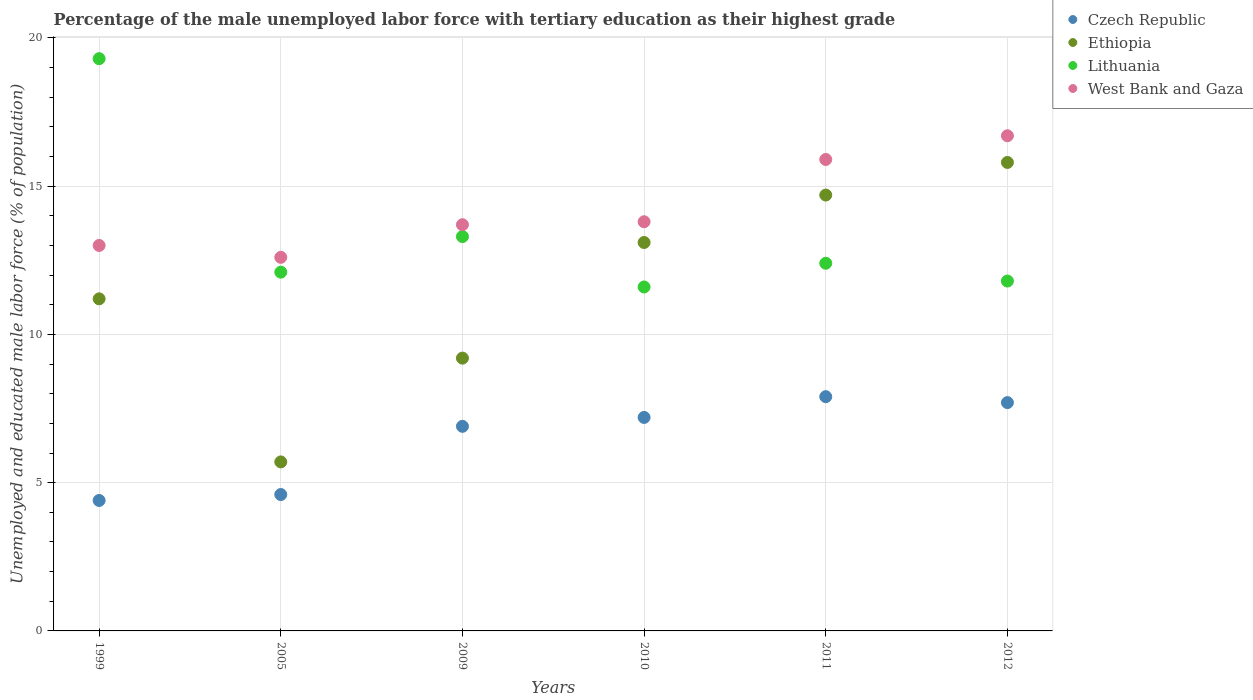Is the number of dotlines equal to the number of legend labels?
Provide a short and direct response. Yes. What is the percentage of the unemployed male labor force with tertiary education in Lithuania in 2010?
Provide a short and direct response. 11.6. Across all years, what is the maximum percentage of the unemployed male labor force with tertiary education in West Bank and Gaza?
Your answer should be very brief. 16.7. Across all years, what is the minimum percentage of the unemployed male labor force with tertiary education in Czech Republic?
Provide a succinct answer. 4.4. What is the total percentage of the unemployed male labor force with tertiary education in Lithuania in the graph?
Your answer should be compact. 80.5. What is the difference between the percentage of the unemployed male labor force with tertiary education in Czech Republic in 2005 and that in 2010?
Provide a short and direct response. -2.6. What is the difference between the percentage of the unemployed male labor force with tertiary education in Lithuania in 2011 and the percentage of the unemployed male labor force with tertiary education in Czech Republic in 2010?
Provide a short and direct response. 5.2. What is the average percentage of the unemployed male labor force with tertiary education in Lithuania per year?
Offer a terse response. 13.42. In the year 2012, what is the difference between the percentage of the unemployed male labor force with tertiary education in Ethiopia and percentage of the unemployed male labor force with tertiary education in West Bank and Gaza?
Offer a terse response. -0.9. What is the ratio of the percentage of the unemployed male labor force with tertiary education in Lithuania in 2005 to that in 2012?
Your answer should be compact. 1.03. Is the percentage of the unemployed male labor force with tertiary education in Lithuania in 2009 less than that in 2010?
Your answer should be very brief. No. What is the difference between the highest and the second highest percentage of the unemployed male labor force with tertiary education in Czech Republic?
Provide a succinct answer. 0.2. What is the difference between the highest and the lowest percentage of the unemployed male labor force with tertiary education in West Bank and Gaza?
Keep it short and to the point. 4.1. In how many years, is the percentage of the unemployed male labor force with tertiary education in West Bank and Gaza greater than the average percentage of the unemployed male labor force with tertiary education in West Bank and Gaza taken over all years?
Provide a succinct answer. 2. Is the sum of the percentage of the unemployed male labor force with tertiary education in Czech Republic in 2010 and 2011 greater than the maximum percentage of the unemployed male labor force with tertiary education in Lithuania across all years?
Make the answer very short. No. Is it the case that in every year, the sum of the percentage of the unemployed male labor force with tertiary education in Czech Republic and percentage of the unemployed male labor force with tertiary education in Lithuania  is greater than the percentage of the unemployed male labor force with tertiary education in Ethiopia?
Make the answer very short. Yes. Does the percentage of the unemployed male labor force with tertiary education in Lithuania monotonically increase over the years?
Your answer should be compact. No. How many years are there in the graph?
Your response must be concise. 6. Where does the legend appear in the graph?
Make the answer very short. Top right. How are the legend labels stacked?
Keep it short and to the point. Vertical. What is the title of the graph?
Make the answer very short. Percentage of the male unemployed labor force with tertiary education as their highest grade. Does "Jamaica" appear as one of the legend labels in the graph?
Make the answer very short. No. What is the label or title of the X-axis?
Make the answer very short. Years. What is the label or title of the Y-axis?
Offer a terse response. Unemployed and educated male labor force (% of population). What is the Unemployed and educated male labor force (% of population) in Czech Republic in 1999?
Ensure brevity in your answer.  4.4. What is the Unemployed and educated male labor force (% of population) in Ethiopia in 1999?
Ensure brevity in your answer.  11.2. What is the Unemployed and educated male labor force (% of population) of Lithuania in 1999?
Offer a terse response. 19.3. What is the Unemployed and educated male labor force (% of population) in Czech Republic in 2005?
Give a very brief answer. 4.6. What is the Unemployed and educated male labor force (% of population) of Ethiopia in 2005?
Keep it short and to the point. 5.7. What is the Unemployed and educated male labor force (% of population) in Lithuania in 2005?
Ensure brevity in your answer.  12.1. What is the Unemployed and educated male labor force (% of population) in West Bank and Gaza in 2005?
Give a very brief answer. 12.6. What is the Unemployed and educated male labor force (% of population) of Czech Republic in 2009?
Your answer should be very brief. 6.9. What is the Unemployed and educated male labor force (% of population) of Ethiopia in 2009?
Give a very brief answer. 9.2. What is the Unemployed and educated male labor force (% of population) in Lithuania in 2009?
Your answer should be compact. 13.3. What is the Unemployed and educated male labor force (% of population) of West Bank and Gaza in 2009?
Provide a short and direct response. 13.7. What is the Unemployed and educated male labor force (% of population) of Czech Republic in 2010?
Provide a succinct answer. 7.2. What is the Unemployed and educated male labor force (% of population) in Ethiopia in 2010?
Offer a very short reply. 13.1. What is the Unemployed and educated male labor force (% of population) in Lithuania in 2010?
Your answer should be compact. 11.6. What is the Unemployed and educated male labor force (% of population) of West Bank and Gaza in 2010?
Offer a terse response. 13.8. What is the Unemployed and educated male labor force (% of population) of Czech Republic in 2011?
Keep it short and to the point. 7.9. What is the Unemployed and educated male labor force (% of population) of Ethiopia in 2011?
Your answer should be compact. 14.7. What is the Unemployed and educated male labor force (% of population) of Lithuania in 2011?
Provide a succinct answer. 12.4. What is the Unemployed and educated male labor force (% of population) in West Bank and Gaza in 2011?
Your answer should be compact. 15.9. What is the Unemployed and educated male labor force (% of population) in Czech Republic in 2012?
Keep it short and to the point. 7.7. What is the Unemployed and educated male labor force (% of population) in Ethiopia in 2012?
Your answer should be very brief. 15.8. What is the Unemployed and educated male labor force (% of population) of Lithuania in 2012?
Your answer should be very brief. 11.8. What is the Unemployed and educated male labor force (% of population) in West Bank and Gaza in 2012?
Offer a terse response. 16.7. Across all years, what is the maximum Unemployed and educated male labor force (% of population) of Czech Republic?
Your response must be concise. 7.9. Across all years, what is the maximum Unemployed and educated male labor force (% of population) of Ethiopia?
Provide a short and direct response. 15.8. Across all years, what is the maximum Unemployed and educated male labor force (% of population) of Lithuania?
Give a very brief answer. 19.3. Across all years, what is the maximum Unemployed and educated male labor force (% of population) of West Bank and Gaza?
Ensure brevity in your answer.  16.7. Across all years, what is the minimum Unemployed and educated male labor force (% of population) of Czech Republic?
Provide a short and direct response. 4.4. Across all years, what is the minimum Unemployed and educated male labor force (% of population) of Ethiopia?
Provide a succinct answer. 5.7. Across all years, what is the minimum Unemployed and educated male labor force (% of population) of Lithuania?
Ensure brevity in your answer.  11.6. Across all years, what is the minimum Unemployed and educated male labor force (% of population) in West Bank and Gaza?
Provide a succinct answer. 12.6. What is the total Unemployed and educated male labor force (% of population) of Czech Republic in the graph?
Give a very brief answer. 38.7. What is the total Unemployed and educated male labor force (% of population) of Ethiopia in the graph?
Keep it short and to the point. 69.7. What is the total Unemployed and educated male labor force (% of population) in Lithuania in the graph?
Your answer should be very brief. 80.5. What is the total Unemployed and educated male labor force (% of population) of West Bank and Gaza in the graph?
Make the answer very short. 85.7. What is the difference between the Unemployed and educated male labor force (% of population) in Lithuania in 1999 and that in 2005?
Offer a very short reply. 7.2. What is the difference between the Unemployed and educated male labor force (% of population) in Ethiopia in 1999 and that in 2009?
Provide a succinct answer. 2. What is the difference between the Unemployed and educated male labor force (% of population) in West Bank and Gaza in 1999 and that in 2009?
Ensure brevity in your answer.  -0.7. What is the difference between the Unemployed and educated male labor force (% of population) in Czech Republic in 1999 and that in 2010?
Make the answer very short. -2.8. What is the difference between the Unemployed and educated male labor force (% of population) in Ethiopia in 1999 and that in 2010?
Offer a very short reply. -1.9. What is the difference between the Unemployed and educated male labor force (% of population) in Czech Republic in 1999 and that in 2012?
Offer a terse response. -3.3. What is the difference between the Unemployed and educated male labor force (% of population) of Ethiopia in 1999 and that in 2012?
Your response must be concise. -4.6. What is the difference between the Unemployed and educated male labor force (% of population) in Lithuania in 1999 and that in 2012?
Provide a short and direct response. 7.5. What is the difference between the Unemployed and educated male labor force (% of population) of Ethiopia in 2005 and that in 2009?
Make the answer very short. -3.5. What is the difference between the Unemployed and educated male labor force (% of population) in West Bank and Gaza in 2005 and that in 2009?
Your answer should be compact. -1.1. What is the difference between the Unemployed and educated male labor force (% of population) of Ethiopia in 2005 and that in 2010?
Keep it short and to the point. -7.4. What is the difference between the Unemployed and educated male labor force (% of population) in Czech Republic in 2005 and that in 2011?
Provide a short and direct response. -3.3. What is the difference between the Unemployed and educated male labor force (% of population) of Ethiopia in 2005 and that in 2011?
Make the answer very short. -9. What is the difference between the Unemployed and educated male labor force (% of population) in Ethiopia in 2005 and that in 2012?
Keep it short and to the point. -10.1. What is the difference between the Unemployed and educated male labor force (% of population) of Lithuania in 2005 and that in 2012?
Provide a short and direct response. 0.3. What is the difference between the Unemployed and educated male labor force (% of population) in Lithuania in 2009 and that in 2010?
Make the answer very short. 1.7. What is the difference between the Unemployed and educated male labor force (% of population) in Ethiopia in 2009 and that in 2011?
Provide a short and direct response. -5.5. What is the difference between the Unemployed and educated male labor force (% of population) in Lithuania in 2009 and that in 2011?
Your answer should be compact. 0.9. What is the difference between the Unemployed and educated male labor force (% of population) in Czech Republic in 2009 and that in 2012?
Make the answer very short. -0.8. What is the difference between the Unemployed and educated male labor force (% of population) in Ethiopia in 2009 and that in 2012?
Give a very brief answer. -6.6. What is the difference between the Unemployed and educated male labor force (% of population) in Lithuania in 2009 and that in 2012?
Keep it short and to the point. 1.5. What is the difference between the Unemployed and educated male labor force (% of population) of West Bank and Gaza in 2009 and that in 2012?
Your answer should be compact. -3. What is the difference between the Unemployed and educated male labor force (% of population) of Lithuania in 2010 and that in 2011?
Ensure brevity in your answer.  -0.8. What is the difference between the Unemployed and educated male labor force (% of population) of Lithuania in 2010 and that in 2012?
Your response must be concise. -0.2. What is the difference between the Unemployed and educated male labor force (% of population) in West Bank and Gaza in 2010 and that in 2012?
Ensure brevity in your answer.  -2.9. What is the difference between the Unemployed and educated male labor force (% of population) in Lithuania in 2011 and that in 2012?
Your answer should be compact. 0.6. What is the difference between the Unemployed and educated male labor force (% of population) in Czech Republic in 1999 and the Unemployed and educated male labor force (% of population) in Ethiopia in 2005?
Keep it short and to the point. -1.3. What is the difference between the Unemployed and educated male labor force (% of population) in Ethiopia in 1999 and the Unemployed and educated male labor force (% of population) in West Bank and Gaza in 2005?
Your answer should be compact. -1.4. What is the difference between the Unemployed and educated male labor force (% of population) in Lithuania in 1999 and the Unemployed and educated male labor force (% of population) in West Bank and Gaza in 2005?
Keep it short and to the point. 6.7. What is the difference between the Unemployed and educated male labor force (% of population) of Czech Republic in 1999 and the Unemployed and educated male labor force (% of population) of Ethiopia in 2009?
Keep it short and to the point. -4.8. What is the difference between the Unemployed and educated male labor force (% of population) in Ethiopia in 1999 and the Unemployed and educated male labor force (% of population) in Lithuania in 2009?
Ensure brevity in your answer.  -2.1. What is the difference between the Unemployed and educated male labor force (% of population) of Ethiopia in 1999 and the Unemployed and educated male labor force (% of population) of West Bank and Gaza in 2009?
Your answer should be very brief. -2.5. What is the difference between the Unemployed and educated male labor force (% of population) of Czech Republic in 1999 and the Unemployed and educated male labor force (% of population) of Ethiopia in 2010?
Provide a short and direct response. -8.7. What is the difference between the Unemployed and educated male labor force (% of population) of Czech Republic in 1999 and the Unemployed and educated male labor force (% of population) of Lithuania in 2010?
Make the answer very short. -7.2. What is the difference between the Unemployed and educated male labor force (% of population) of Czech Republic in 1999 and the Unemployed and educated male labor force (% of population) of West Bank and Gaza in 2010?
Your response must be concise. -9.4. What is the difference between the Unemployed and educated male labor force (% of population) in Ethiopia in 1999 and the Unemployed and educated male labor force (% of population) in Lithuania in 2010?
Provide a short and direct response. -0.4. What is the difference between the Unemployed and educated male labor force (% of population) in Lithuania in 1999 and the Unemployed and educated male labor force (% of population) in West Bank and Gaza in 2010?
Provide a succinct answer. 5.5. What is the difference between the Unemployed and educated male labor force (% of population) in Czech Republic in 1999 and the Unemployed and educated male labor force (% of population) in Ethiopia in 2011?
Keep it short and to the point. -10.3. What is the difference between the Unemployed and educated male labor force (% of population) of Czech Republic in 1999 and the Unemployed and educated male labor force (% of population) of Lithuania in 2011?
Make the answer very short. -8. What is the difference between the Unemployed and educated male labor force (% of population) of Ethiopia in 1999 and the Unemployed and educated male labor force (% of population) of Lithuania in 2011?
Provide a succinct answer. -1.2. What is the difference between the Unemployed and educated male labor force (% of population) in Lithuania in 1999 and the Unemployed and educated male labor force (% of population) in West Bank and Gaza in 2011?
Provide a succinct answer. 3.4. What is the difference between the Unemployed and educated male labor force (% of population) of Czech Republic in 1999 and the Unemployed and educated male labor force (% of population) of Ethiopia in 2012?
Your answer should be very brief. -11.4. What is the difference between the Unemployed and educated male labor force (% of population) in Czech Republic in 1999 and the Unemployed and educated male labor force (% of population) in West Bank and Gaza in 2012?
Make the answer very short. -12.3. What is the difference between the Unemployed and educated male labor force (% of population) in Ethiopia in 1999 and the Unemployed and educated male labor force (% of population) in Lithuania in 2012?
Provide a short and direct response. -0.6. What is the difference between the Unemployed and educated male labor force (% of population) in Ethiopia in 1999 and the Unemployed and educated male labor force (% of population) in West Bank and Gaza in 2012?
Offer a terse response. -5.5. What is the difference between the Unemployed and educated male labor force (% of population) of Czech Republic in 2005 and the Unemployed and educated male labor force (% of population) of West Bank and Gaza in 2009?
Offer a terse response. -9.1. What is the difference between the Unemployed and educated male labor force (% of population) in Ethiopia in 2005 and the Unemployed and educated male labor force (% of population) in Lithuania in 2009?
Provide a short and direct response. -7.6. What is the difference between the Unemployed and educated male labor force (% of population) of Lithuania in 2005 and the Unemployed and educated male labor force (% of population) of West Bank and Gaza in 2009?
Keep it short and to the point. -1.6. What is the difference between the Unemployed and educated male labor force (% of population) of Ethiopia in 2005 and the Unemployed and educated male labor force (% of population) of Lithuania in 2010?
Give a very brief answer. -5.9. What is the difference between the Unemployed and educated male labor force (% of population) in Ethiopia in 2005 and the Unemployed and educated male labor force (% of population) in West Bank and Gaza in 2010?
Provide a succinct answer. -8.1. What is the difference between the Unemployed and educated male labor force (% of population) in Czech Republic in 2005 and the Unemployed and educated male labor force (% of population) in Ethiopia in 2011?
Offer a terse response. -10.1. What is the difference between the Unemployed and educated male labor force (% of population) in Czech Republic in 2005 and the Unemployed and educated male labor force (% of population) in Lithuania in 2011?
Ensure brevity in your answer.  -7.8. What is the difference between the Unemployed and educated male labor force (% of population) of Czech Republic in 2005 and the Unemployed and educated male labor force (% of population) of West Bank and Gaza in 2011?
Make the answer very short. -11.3. What is the difference between the Unemployed and educated male labor force (% of population) in Ethiopia in 2005 and the Unemployed and educated male labor force (% of population) in Lithuania in 2011?
Give a very brief answer. -6.7. What is the difference between the Unemployed and educated male labor force (% of population) of Ethiopia in 2005 and the Unemployed and educated male labor force (% of population) of West Bank and Gaza in 2012?
Offer a very short reply. -11. What is the difference between the Unemployed and educated male labor force (% of population) in Czech Republic in 2009 and the Unemployed and educated male labor force (% of population) in Ethiopia in 2010?
Make the answer very short. -6.2. What is the difference between the Unemployed and educated male labor force (% of population) of Czech Republic in 2009 and the Unemployed and educated male labor force (% of population) of Lithuania in 2010?
Ensure brevity in your answer.  -4.7. What is the difference between the Unemployed and educated male labor force (% of population) in Czech Republic in 2009 and the Unemployed and educated male labor force (% of population) in West Bank and Gaza in 2010?
Make the answer very short. -6.9. What is the difference between the Unemployed and educated male labor force (% of population) in Lithuania in 2009 and the Unemployed and educated male labor force (% of population) in West Bank and Gaza in 2010?
Ensure brevity in your answer.  -0.5. What is the difference between the Unemployed and educated male labor force (% of population) of Czech Republic in 2009 and the Unemployed and educated male labor force (% of population) of Ethiopia in 2011?
Keep it short and to the point. -7.8. What is the difference between the Unemployed and educated male labor force (% of population) of Czech Republic in 2009 and the Unemployed and educated male labor force (% of population) of Lithuania in 2011?
Give a very brief answer. -5.5. What is the difference between the Unemployed and educated male labor force (% of population) in Czech Republic in 2009 and the Unemployed and educated male labor force (% of population) in West Bank and Gaza in 2011?
Make the answer very short. -9. What is the difference between the Unemployed and educated male labor force (% of population) of Ethiopia in 2009 and the Unemployed and educated male labor force (% of population) of Lithuania in 2011?
Ensure brevity in your answer.  -3.2. What is the difference between the Unemployed and educated male labor force (% of population) in Ethiopia in 2009 and the Unemployed and educated male labor force (% of population) in West Bank and Gaza in 2011?
Offer a very short reply. -6.7. What is the difference between the Unemployed and educated male labor force (% of population) in Czech Republic in 2009 and the Unemployed and educated male labor force (% of population) in Lithuania in 2012?
Your response must be concise. -4.9. What is the difference between the Unemployed and educated male labor force (% of population) of Ethiopia in 2009 and the Unemployed and educated male labor force (% of population) of West Bank and Gaza in 2012?
Keep it short and to the point. -7.5. What is the difference between the Unemployed and educated male labor force (% of population) in Lithuania in 2009 and the Unemployed and educated male labor force (% of population) in West Bank and Gaza in 2012?
Provide a succinct answer. -3.4. What is the difference between the Unemployed and educated male labor force (% of population) in Czech Republic in 2010 and the Unemployed and educated male labor force (% of population) in Ethiopia in 2011?
Your answer should be compact. -7.5. What is the difference between the Unemployed and educated male labor force (% of population) of Czech Republic in 2010 and the Unemployed and educated male labor force (% of population) of West Bank and Gaza in 2011?
Make the answer very short. -8.7. What is the difference between the Unemployed and educated male labor force (% of population) of Ethiopia in 2010 and the Unemployed and educated male labor force (% of population) of West Bank and Gaza in 2011?
Ensure brevity in your answer.  -2.8. What is the difference between the Unemployed and educated male labor force (% of population) of Czech Republic in 2010 and the Unemployed and educated male labor force (% of population) of Ethiopia in 2012?
Provide a succinct answer. -8.6. What is the difference between the Unemployed and educated male labor force (% of population) of Ethiopia in 2010 and the Unemployed and educated male labor force (% of population) of Lithuania in 2012?
Provide a succinct answer. 1.3. What is the difference between the Unemployed and educated male labor force (% of population) in Czech Republic in 2011 and the Unemployed and educated male labor force (% of population) in Ethiopia in 2012?
Your answer should be compact. -7.9. What is the difference between the Unemployed and educated male labor force (% of population) of Czech Republic in 2011 and the Unemployed and educated male labor force (% of population) of Lithuania in 2012?
Offer a very short reply. -3.9. What is the difference between the Unemployed and educated male labor force (% of population) in Czech Republic in 2011 and the Unemployed and educated male labor force (% of population) in West Bank and Gaza in 2012?
Give a very brief answer. -8.8. What is the difference between the Unemployed and educated male labor force (% of population) in Ethiopia in 2011 and the Unemployed and educated male labor force (% of population) in Lithuania in 2012?
Provide a short and direct response. 2.9. What is the difference between the Unemployed and educated male labor force (% of population) of Ethiopia in 2011 and the Unemployed and educated male labor force (% of population) of West Bank and Gaza in 2012?
Provide a short and direct response. -2. What is the difference between the Unemployed and educated male labor force (% of population) of Lithuania in 2011 and the Unemployed and educated male labor force (% of population) of West Bank and Gaza in 2012?
Your response must be concise. -4.3. What is the average Unemployed and educated male labor force (% of population) in Czech Republic per year?
Your answer should be very brief. 6.45. What is the average Unemployed and educated male labor force (% of population) of Ethiopia per year?
Offer a very short reply. 11.62. What is the average Unemployed and educated male labor force (% of population) in Lithuania per year?
Make the answer very short. 13.42. What is the average Unemployed and educated male labor force (% of population) of West Bank and Gaza per year?
Offer a terse response. 14.28. In the year 1999, what is the difference between the Unemployed and educated male labor force (% of population) of Czech Republic and Unemployed and educated male labor force (% of population) of Lithuania?
Keep it short and to the point. -14.9. In the year 2005, what is the difference between the Unemployed and educated male labor force (% of population) of Czech Republic and Unemployed and educated male labor force (% of population) of Ethiopia?
Your answer should be compact. -1.1. In the year 2005, what is the difference between the Unemployed and educated male labor force (% of population) in Czech Republic and Unemployed and educated male labor force (% of population) in West Bank and Gaza?
Provide a short and direct response. -8. In the year 2005, what is the difference between the Unemployed and educated male labor force (% of population) in Lithuania and Unemployed and educated male labor force (% of population) in West Bank and Gaza?
Your response must be concise. -0.5. In the year 2009, what is the difference between the Unemployed and educated male labor force (% of population) of Czech Republic and Unemployed and educated male labor force (% of population) of Ethiopia?
Keep it short and to the point. -2.3. In the year 2009, what is the difference between the Unemployed and educated male labor force (% of population) of Czech Republic and Unemployed and educated male labor force (% of population) of Lithuania?
Provide a succinct answer. -6.4. In the year 2010, what is the difference between the Unemployed and educated male labor force (% of population) in Czech Republic and Unemployed and educated male labor force (% of population) in Ethiopia?
Your response must be concise. -5.9. In the year 2010, what is the difference between the Unemployed and educated male labor force (% of population) of Czech Republic and Unemployed and educated male labor force (% of population) of West Bank and Gaza?
Provide a short and direct response. -6.6. In the year 2010, what is the difference between the Unemployed and educated male labor force (% of population) in Ethiopia and Unemployed and educated male labor force (% of population) in West Bank and Gaza?
Provide a succinct answer. -0.7. In the year 2010, what is the difference between the Unemployed and educated male labor force (% of population) in Lithuania and Unemployed and educated male labor force (% of population) in West Bank and Gaza?
Make the answer very short. -2.2. In the year 2011, what is the difference between the Unemployed and educated male labor force (% of population) of Czech Republic and Unemployed and educated male labor force (% of population) of Ethiopia?
Make the answer very short. -6.8. In the year 2011, what is the difference between the Unemployed and educated male labor force (% of population) of Czech Republic and Unemployed and educated male labor force (% of population) of Lithuania?
Offer a very short reply. -4.5. In the year 2011, what is the difference between the Unemployed and educated male labor force (% of population) in Ethiopia and Unemployed and educated male labor force (% of population) in Lithuania?
Give a very brief answer. 2.3. In the year 2011, what is the difference between the Unemployed and educated male labor force (% of population) in Ethiopia and Unemployed and educated male labor force (% of population) in West Bank and Gaza?
Ensure brevity in your answer.  -1.2. In the year 2012, what is the difference between the Unemployed and educated male labor force (% of population) of Czech Republic and Unemployed and educated male labor force (% of population) of Ethiopia?
Offer a terse response. -8.1. In the year 2012, what is the difference between the Unemployed and educated male labor force (% of population) in Ethiopia and Unemployed and educated male labor force (% of population) in West Bank and Gaza?
Your answer should be compact. -0.9. What is the ratio of the Unemployed and educated male labor force (% of population) of Czech Republic in 1999 to that in 2005?
Your answer should be compact. 0.96. What is the ratio of the Unemployed and educated male labor force (% of population) in Ethiopia in 1999 to that in 2005?
Give a very brief answer. 1.96. What is the ratio of the Unemployed and educated male labor force (% of population) in Lithuania in 1999 to that in 2005?
Your answer should be compact. 1.59. What is the ratio of the Unemployed and educated male labor force (% of population) in West Bank and Gaza in 1999 to that in 2005?
Ensure brevity in your answer.  1.03. What is the ratio of the Unemployed and educated male labor force (% of population) of Czech Republic in 1999 to that in 2009?
Your response must be concise. 0.64. What is the ratio of the Unemployed and educated male labor force (% of population) in Ethiopia in 1999 to that in 2009?
Provide a short and direct response. 1.22. What is the ratio of the Unemployed and educated male labor force (% of population) of Lithuania in 1999 to that in 2009?
Keep it short and to the point. 1.45. What is the ratio of the Unemployed and educated male labor force (% of population) of West Bank and Gaza in 1999 to that in 2009?
Give a very brief answer. 0.95. What is the ratio of the Unemployed and educated male labor force (% of population) in Czech Republic in 1999 to that in 2010?
Keep it short and to the point. 0.61. What is the ratio of the Unemployed and educated male labor force (% of population) in Ethiopia in 1999 to that in 2010?
Give a very brief answer. 0.85. What is the ratio of the Unemployed and educated male labor force (% of population) of Lithuania in 1999 to that in 2010?
Offer a terse response. 1.66. What is the ratio of the Unemployed and educated male labor force (% of population) in West Bank and Gaza in 1999 to that in 2010?
Provide a short and direct response. 0.94. What is the ratio of the Unemployed and educated male labor force (% of population) in Czech Republic in 1999 to that in 2011?
Ensure brevity in your answer.  0.56. What is the ratio of the Unemployed and educated male labor force (% of population) in Ethiopia in 1999 to that in 2011?
Offer a very short reply. 0.76. What is the ratio of the Unemployed and educated male labor force (% of population) of Lithuania in 1999 to that in 2011?
Your answer should be compact. 1.56. What is the ratio of the Unemployed and educated male labor force (% of population) of West Bank and Gaza in 1999 to that in 2011?
Your response must be concise. 0.82. What is the ratio of the Unemployed and educated male labor force (% of population) of Ethiopia in 1999 to that in 2012?
Make the answer very short. 0.71. What is the ratio of the Unemployed and educated male labor force (% of population) in Lithuania in 1999 to that in 2012?
Offer a very short reply. 1.64. What is the ratio of the Unemployed and educated male labor force (% of population) of West Bank and Gaza in 1999 to that in 2012?
Give a very brief answer. 0.78. What is the ratio of the Unemployed and educated male labor force (% of population) of Ethiopia in 2005 to that in 2009?
Your answer should be compact. 0.62. What is the ratio of the Unemployed and educated male labor force (% of population) in Lithuania in 2005 to that in 2009?
Ensure brevity in your answer.  0.91. What is the ratio of the Unemployed and educated male labor force (% of population) of West Bank and Gaza in 2005 to that in 2009?
Ensure brevity in your answer.  0.92. What is the ratio of the Unemployed and educated male labor force (% of population) in Czech Republic in 2005 to that in 2010?
Ensure brevity in your answer.  0.64. What is the ratio of the Unemployed and educated male labor force (% of population) of Ethiopia in 2005 to that in 2010?
Keep it short and to the point. 0.44. What is the ratio of the Unemployed and educated male labor force (% of population) of Lithuania in 2005 to that in 2010?
Keep it short and to the point. 1.04. What is the ratio of the Unemployed and educated male labor force (% of population) in Czech Republic in 2005 to that in 2011?
Ensure brevity in your answer.  0.58. What is the ratio of the Unemployed and educated male labor force (% of population) in Ethiopia in 2005 to that in 2011?
Ensure brevity in your answer.  0.39. What is the ratio of the Unemployed and educated male labor force (% of population) of Lithuania in 2005 to that in 2011?
Make the answer very short. 0.98. What is the ratio of the Unemployed and educated male labor force (% of population) in West Bank and Gaza in 2005 to that in 2011?
Make the answer very short. 0.79. What is the ratio of the Unemployed and educated male labor force (% of population) in Czech Republic in 2005 to that in 2012?
Ensure brevity in your answer.  0.6. What is the ratio of the Unemployed and educated male labor force (% of population) in Ethiopia in 2005 to that in 2012?
Your response must be concise. 0.36. What is the ratio of the Unemployed and educated male labor force (% of population) of Lithuania in 2005 to that in 2012?
Offer a very short reply. 1.03. What is the ratio of the Unemployed and educated male labor force (% of population) in West Bank and Gaza in 2005 to that in 2012?
Your response must be concise. 0.75. What is the ratio of the Unemployed and educated male labor force (% of population) of Ethiopia in 2009 to that in 2010?
Offer a very short reply. 0.7. What is the ratio of the Unemployed and educated male labor force (% of population) of Lithuania in 2009 to that in 2010?
Keep it short and to the point. 1.15. What is the ratio of the Unemployed and educated male labor force (% of population) in Czech Republic in 2009 to that in 2011?
Keep it short and to the point. 0.87. What is the ratio of the Unemployed and educated male labor force (% of population) in Ethiopia in 2009 to that in 2011?
Your answer should be compact. 0.63. What is the ratio of the Unemployed and educated male labor force (% of population) of Lithuania in 2009 to that in 2011?
Make the answer very short. 1.07. What is the ratio of the Unemployed and educated male labor force (% of population) of West Bank and Gaza in 2009 to that in 2011?
Make the answer very short. 0.86. What is the ratio of the Unemployed and educated male labor force (% of population) in Czech Republic in 2009 to that in 2012?
Your response must be concise. 0.9. What is the ratio of the Unemployed and educated male labor force (% of population) in Ethiopia in 2009 to that in 2012?
Give a very brief answer. 0.58. What is the ratio of the Unemployed and educated male labor force (% of population) of Lithuania in 2009 to that in 2012?
Provide a short and direct response. 1.13. What is the ratio of the Unemployed and educated male labor force (% of population) in West Bank and Gaza in 2009 to that in 2012?
Offer a very short reply. 0.82. What is the ratio of the Unemployed and educated male labor force (% of population) in Czech Republic in 2010 to that in 2011?
Give a very brief answer. 0.91. What is the ratio of the Unemployed and educated male labor force (% of population) of Ethiopia in 2010 to that in 2011?
Offer a terse response. 0.89. What is the ratio of the Unemployed and educated male labor force (% of population) of Lithuania in 2010 to that in 2011?
Make the answer very short. 0.94. What is the ratio of the Unemployed and educated male labor force (% of population) in West Bank and Gaza in 2010 to that in 2011?
Offer a very short reply. 0.87. What is the ratio of the Unemployed and educated male labor force (% of population) of Czech Republic in 2010 to that in 2012?
Offer a very short reply. 0.94. What is the ratio of the Unemployed and educated male labor force (% of population) in Ethiopia in 2010 to that in 2012?
Offer a very short reply. 0.83. What is the ratio of the Unemployed and educated male labor force (% of population) of Lithuania in 2010 to that in 2012?
Your answer should be very brief. 0.98. What is the ratio of the Unemployed and educated male labor force (% of population) of West Bank and Gaza in 2010 to that in 2012?
Your answer should be compact. 0.83. What is the ratio of the Unemployed and educated male labor force (% of population) of Czech Republic in 2011 to that in 2012?
Keep it short and to the point. 1.03. What is the ratio of the Unemployed and educated male labor force (% of population) of Ethiopia in 2011 to that in 2012?
Your answer should be very brief. 0.93. What is the ratio of the Unemployed and educated male labor force (% of population) in Lithuania in 2011 to that in 2012?
Keep it short and to the point. 1.05. What is the ratio of the Unemployed and educated male labor force (% of population) in West Bank and Gaza in 2011 to that in 2012?
Ensure brevity in your answer.  0.95. What is the difference between the highest and the second highest Unemployed and educated male labor force (% of population) of Czech Republic?
Offer a very short reply. 0.2. What is the difference between the highest and the second highest Unemployed and educated male labor force (% of population) in West Bank and Gaza?
Provide a short and direct response. 0.8. What is the difference between the highest and the lowest Unemployed and educated male labor force (% of population) in Ethiopia?
Provide a succinct answer. 10.1. 